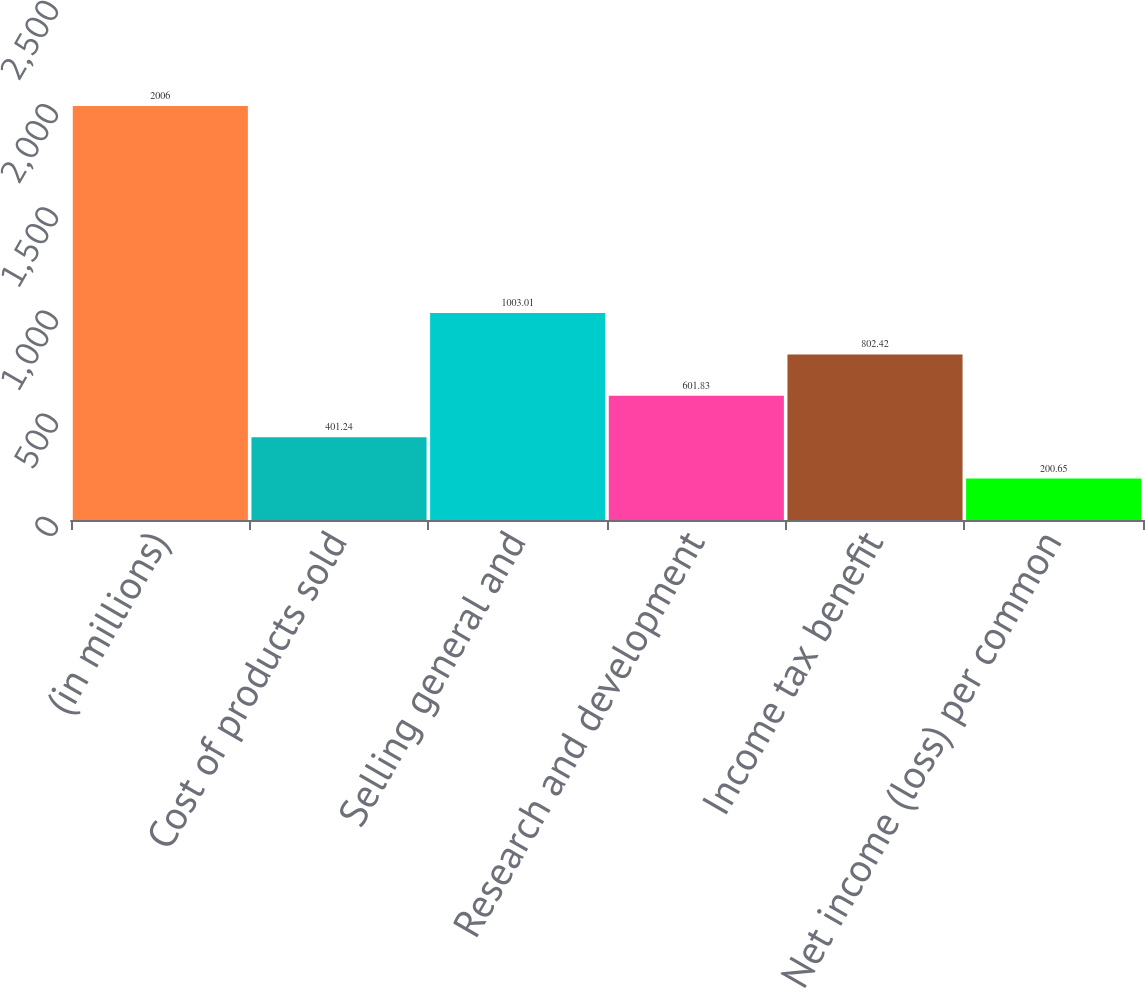<chart> <loc_0><loc_0><loc_500><loc_500><bar_chart><fcel>(in millions)<fcel>Cost of products sold<fcel>Selling general and<fcel>Research and development<fcel>Income tax benefit<fcel>Net income (loss) per common<nl><fcel>2006<fcel>401.24<fcel>1003.01<fcel>601.83<fcel>802.42<fcel>200.65<nl></chart> 